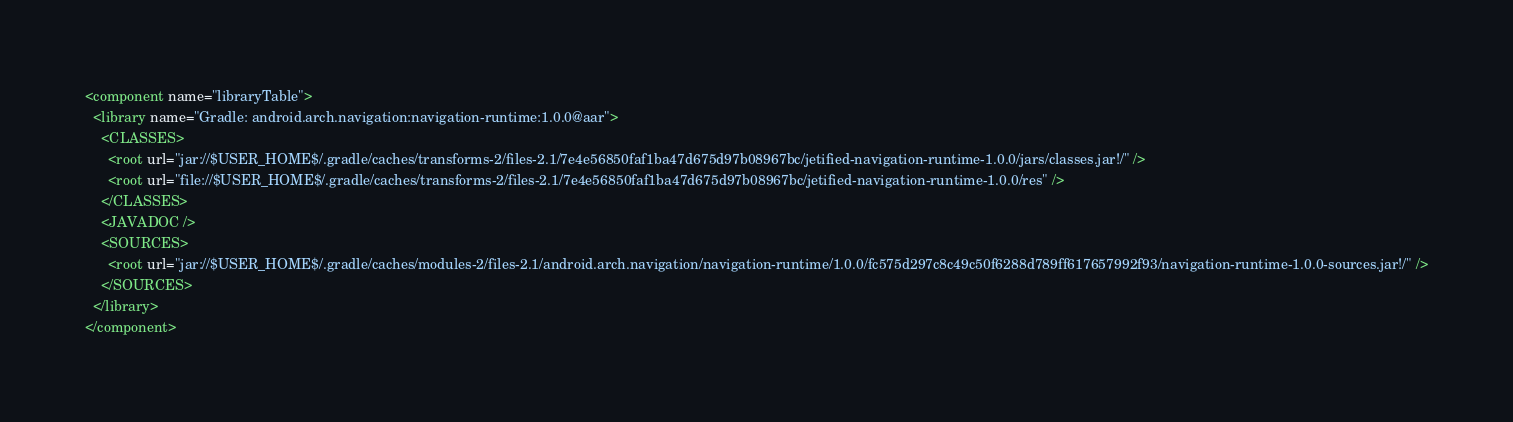Convert code to text. <code><loc_0><loc_0><loc_500><loc_500><_XML_><component name="libraryTable">
  <library name="Gradle: android.arch.navigation:navigation-runtime:1.0.0@aar">
    <CLASSES>
      <root url="jar://$USER_HOME$/.gradle/caches/transforms-2/files-2.1/7e4e56850faf1ba47d675d97b08967bc/jetified-navigation-runtime-1.0.0/jars/classes.jar!/" />
      <root url="file://$USER_HOME$/.gradle/caches/transforms-2/files-2.1/7e4e56850faf1ba47d675d97b08967bc/jetified-navigation-runtime-1.0.0/res" />
    </CLASSES>
    <JAVADOC />
    <SOURCES>
      <root url="jar://$USER_HOME$/.gradle/caches/modules-2/files-2.1/android.arch.navigation/navigation-runtime/1.0.0/fc575d297c8c49c50f6288d789ff617657992f93/navigation-runtime-1.0.0-sources.jar!/" />
    </SOURCES>
  </library>
</component></code> 